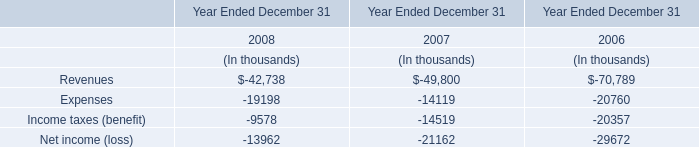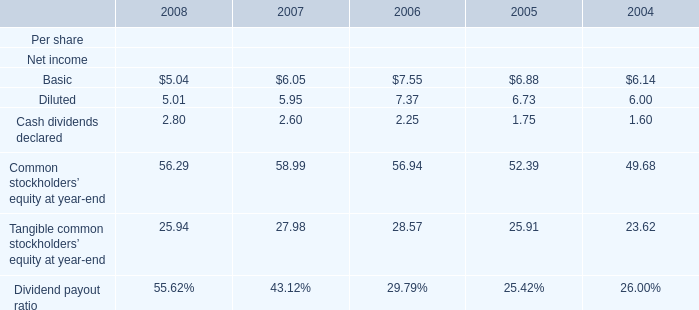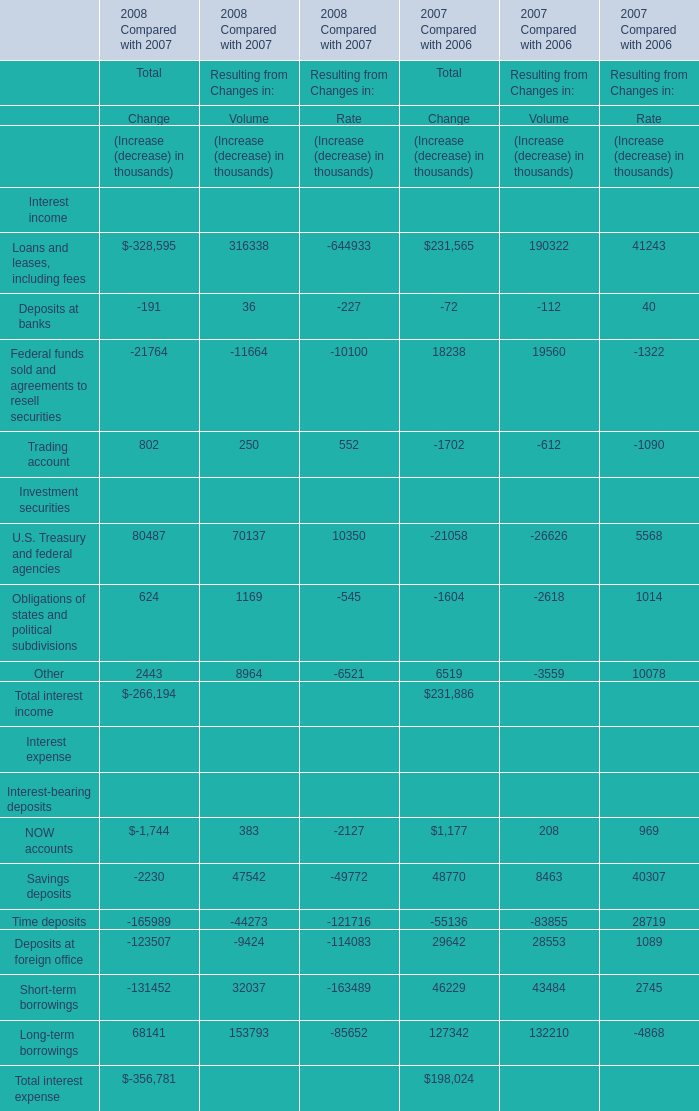What is the total value of Basic Diluted, Cash dividends declared and Common stockholders’ equity at year-end in in 2008? 
Computations: (((5.04 + 5.01) + 2.8) + 56.29)
Answer: 69.14. 